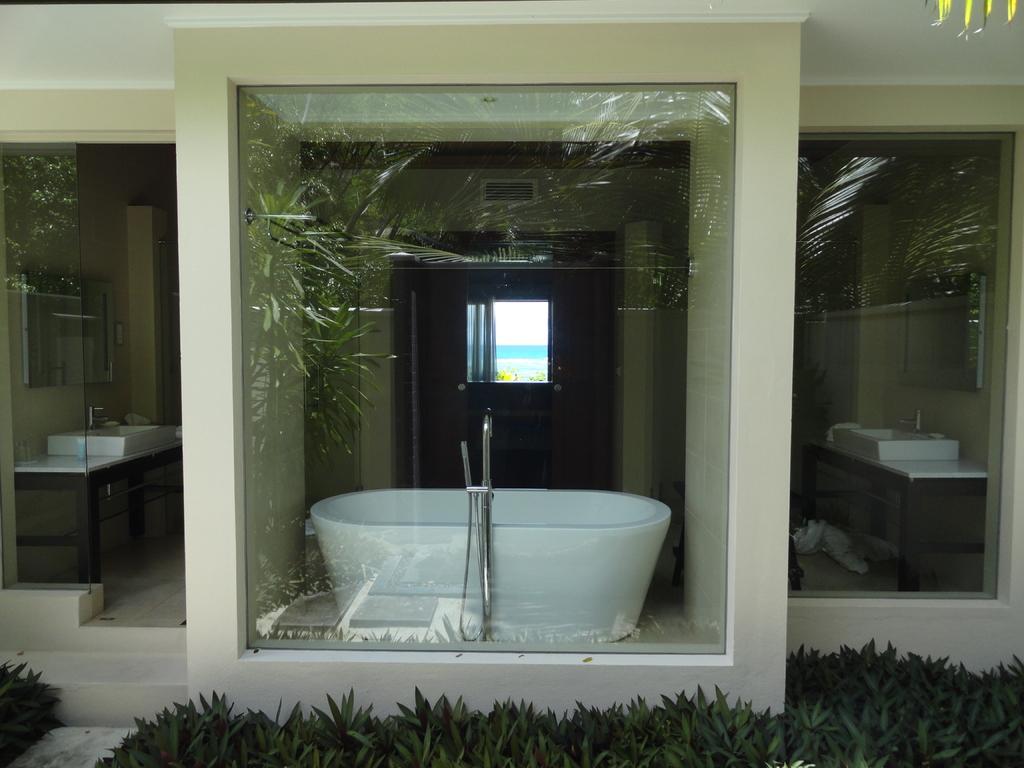Describe this image in one or two sentences. In this picture we can see plants and glass, through glass we can see bathtub, tap, sinks with taps, walls and window. 